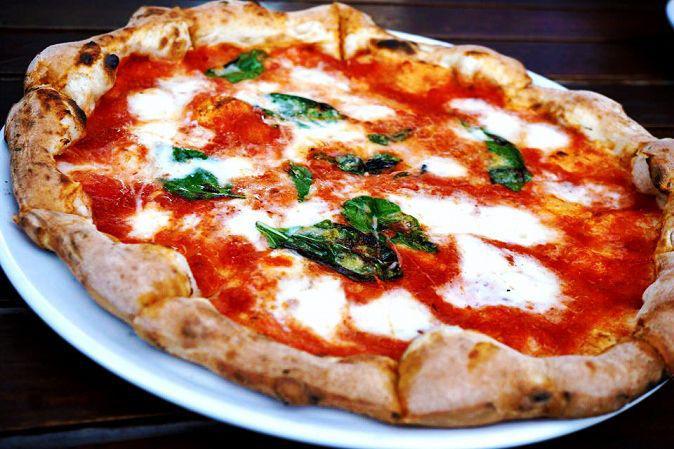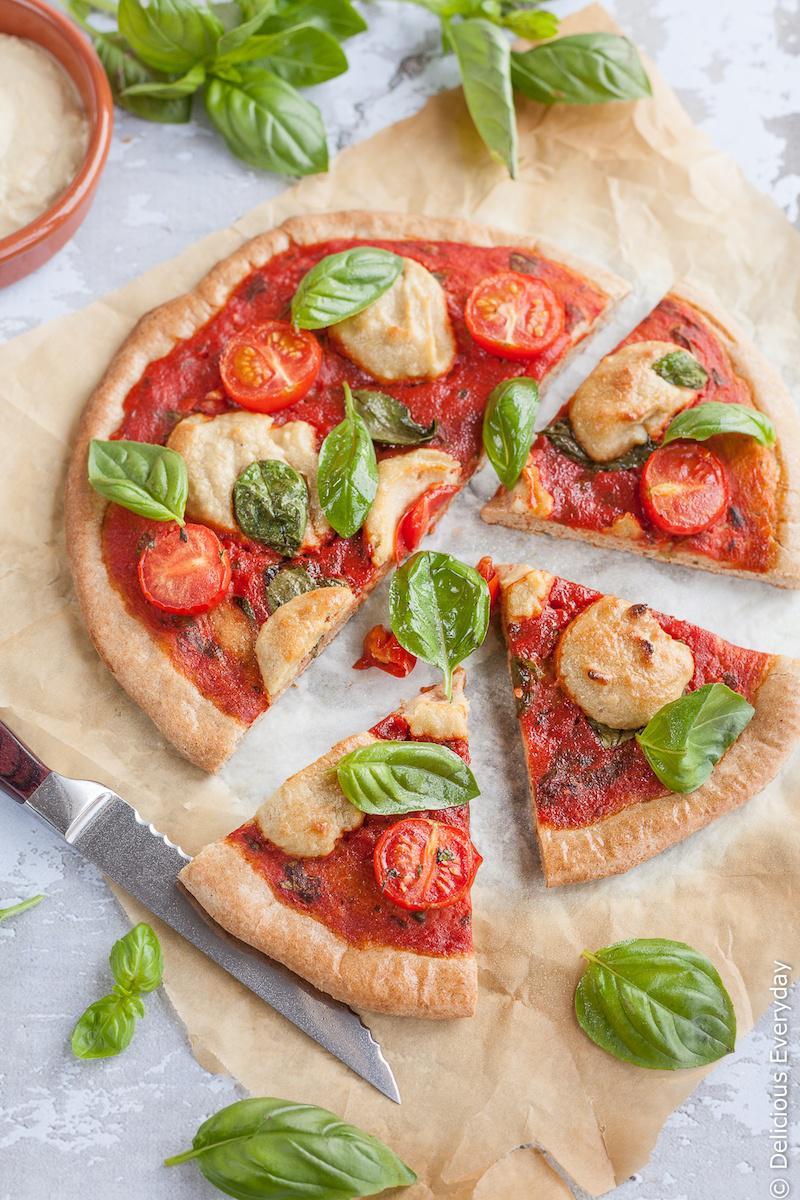The first image is the image on the left, the second image is the image on the right. Evaluate the accuracy of this statement regarding the images: "There is an uncut pizza in the right image.". Is it true? Answer yes or no. No. The first image is the image on the left, the second image is the image on the right. Evaluate the accuracy of this statement regarding the images: "There are two circle pizzas each on a plate or pan.". Is it true? Answer yes or no. No. 